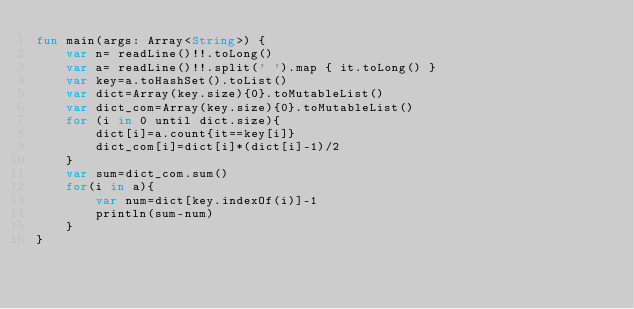<code> <loc_0><loc_0><loc_500><loc_500><_Kotlin_>fun main(args: Array<String>) {
    var n= readLine()!!.toLong()
    var a= readLine()!!.split(' ').map { it.toLong() }
    var key=a.toHashSet().toList()
    var dict=Array(key.size){0}.toMutableList()
    var dict_com=Array(key.size){0}.toMutableList()
    for (i in 0 until dict.size){
        dict[i]=a.count{it==key[i]}
        dict_com[i]=dict[i]*(dict[i]-1)/2
    }
    var sum=dict_com.sum()
    for(i in a){
        var num=dict[key.indexOf(i)]-1
        println(sum-num)
    }
}</code> 